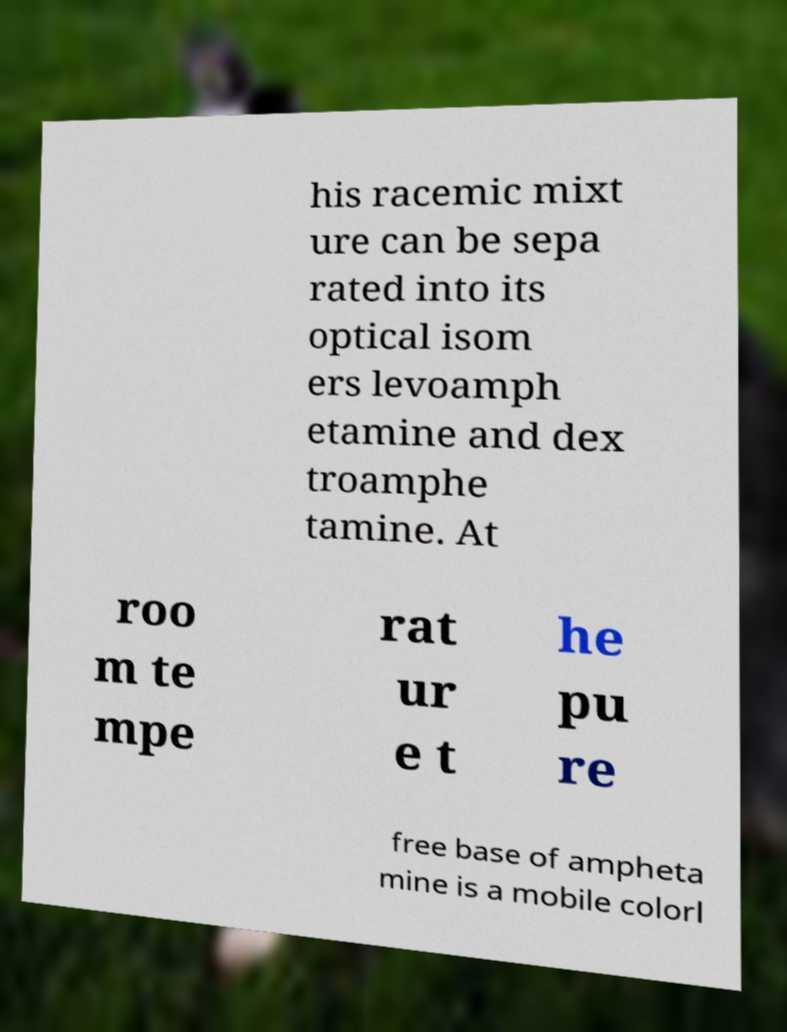Could you assist in decoding the text presented in this image and type it out clearly? his racemic mixt ure can be sepa rated into its optical isom ers levoamph etamine and dex troamphe tamine. At roo m te mpe rat ur e t he pu re free base of ampheta mine is a mobile colorl 